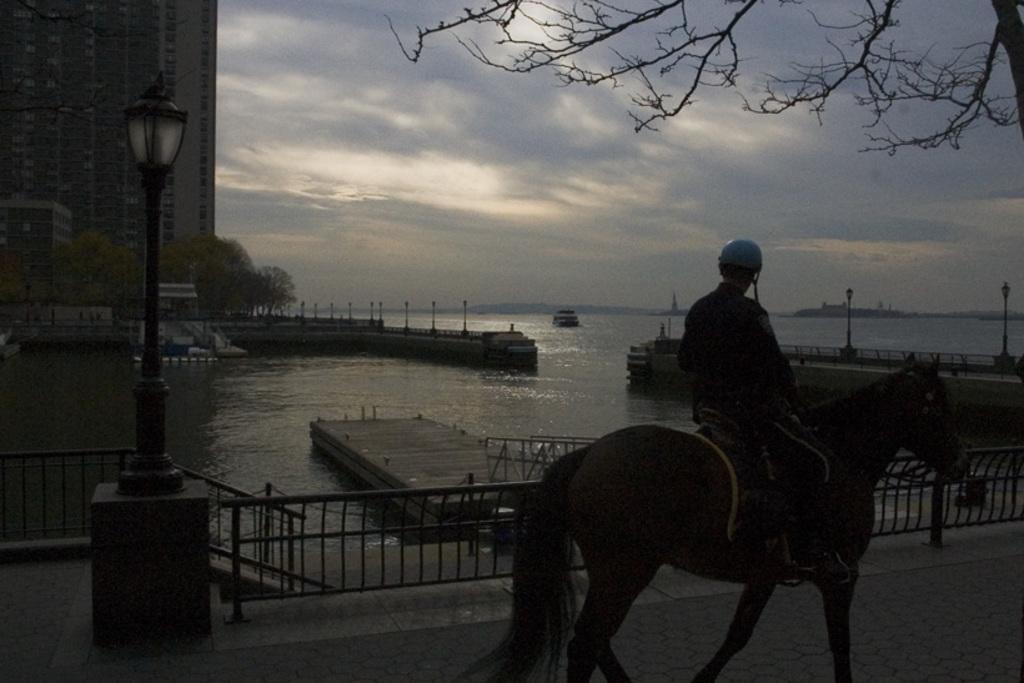Could you give a brief overview of what you see in this image? In the image we can see there is a man who is sitting on horse and there is a clear sky and between there is a river. 